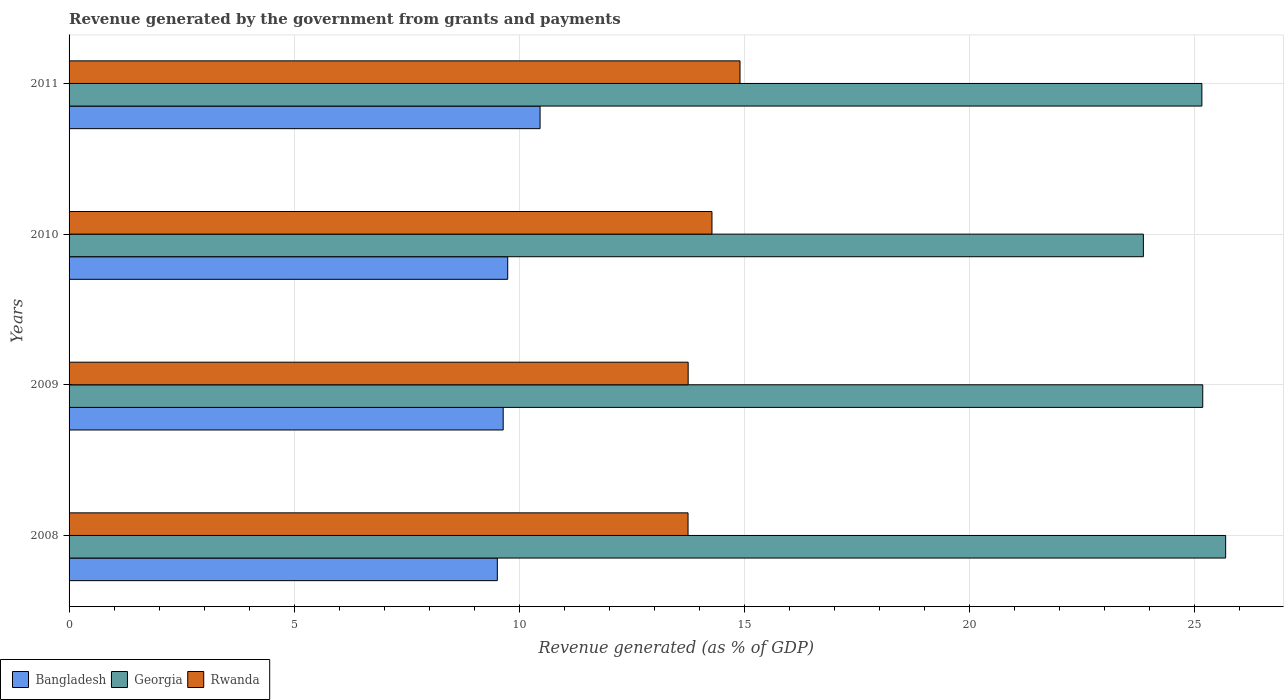How many different coloured bars are there?
Offer a very short reply. 3. How many bars are there on the 2nd tick from the top?
Give a very brief answer. 3. What is the revenue generated by the government in Bangladesh in 2011?
Make the answer very short. 10.46. Across all years, what is the maximum revenue generated by the government in Bangladesh?
Ensure brevity in your answer.  10.46. Across all years, what is the minimum revenue generated by the government in Bangladesh?
Your answer should be very brief. 9.51. What is the total revenue generated by the government in Georgia in the graph?
Provide a short and direct response. 99.9. What is the difference between the revenue generated by the government in Bangladesh in 2008 and that in 2010?
Your response must be concise. -0.23. What is the difference between the revenue generated by the government in Bangladesh in 2010 and the revenue generated by the government in Rwanda in 2008?
Your response must be concise. -4.01. What is the average revenue generated by the government in Bangladesh per year?
Provide a short and direct response. 9.84. In the year 2011, what is the difference between the revenue generated by the government in Georgia and revenue generated by the government in Rwanda?
Give a very brief answer. 10.26. What is the ratio of the revenue generated by the government in Georgia in 2009 to that in 2011?
Provide a succinct answer. 1. Is the revenue generated by the government in Rwanda in 2008 less than that in 2009?
Make the answer very short. Yes. Is the difference between the revenue generated by the government in Georgia in 2010 and 2011 greater than the difference between the revenue generated by the government in Rwanda in 2010 and 2011?
Your answer should be compact. No. What is the difference between the highest and the second highest revenue generated by the government in Bangladesh?
Your response must be concise. 0.72. What is the difference between the highest and the lowest revenue generated by the government in Rwanda?
Provide a short and direct response. 1.15. In how many years, is the revenue generated by the government in Rwanda greater than the average revenue generated by the government in Rwanda taken over all years?
Offer a terse response. 2. Is the sum of the revenue generated by the government in Rwanda in 2009 and 2010 greater than the maximum revenue generated by the government in Georgia across all years?
Offer a terse response. Yes. What does the 2nd bar from the top in 2010 represents?
Provide a succinct answer. Georgia. Does the graph contain grids?
Provide a short and direct response. Yes. Where does the legend appear in the graph?
Provide a succinct answer. Bottom left. How many legend labels are there?
Provide a short and direct response. 3. How are the legend labels stacked?
Offer a very short reply. Horizontal. What is the title of the graph?
Provide a short and direct response. Revenue generated by the government from grants and payments. What is the label or title of the X-axis?
Ensure brevity in your answer.  Revenue generated (as % of GDP). What is the label or title of the Y-axis?
Provide a short and direct response. Years. What is the Revenue generated (as % of GDP) of Bangladesh in 2008?
Offer a terse response. 9.51. What is the Revenue generated (as % of GDP) in Georgia in 2008?
Your answer should be compact. 25.69. What is the Revenue generated (as % of GDP) in Rwanda in 2008?
Your answer should be very brief. 13.75. What is the Revenue generated (as % of GDP) of Bangladesh in 2009?
Offer a terse response. 9.64. What is the Revenue generated (as % of GDP) of Georgia in 2009?
Offer a very short reply. 25.18. What is the Revenue generated (as % of GDP) in Rwanda in 2009?
Keep it short and to the point. 13.75. What is the Revenue generated (as % of GDP) in Bangladesh in 2010?
Your answer should be very brief. 9.74. What is the Revenue generated (as % of GDP) of Georgia in 2010?
Offer a terse response. 23.86. What is the Revenue generated (as % of GDP) of Rwanda in 2010?
Ensure brevity in your answer.  14.28. What is the Revenue generated (as % of GDP) in Bangladesh in 2011?
Ensure brevity in your answer.  10.46. What is the Revenue generated (as % of GDP) of Georgia in 2011?
Give a very brief answer. 25.16. What is the Revenue generated (as % of GDP) in Rwanda in 2011?
Keep it short and to the point. 14.9. Across all years, what is the maximum Revenue generated (as % of GDP) in Bangladesh?
Provide a succinct answer. 10.46. Across all years, what is the maximum Revenue generated (as % of GDP) of Georgia?
Provide a short and direct response. 25.69. Across all years, what is the maximum Revenue generated (as % of GDP) in Rwanda?
Your response must be concise. 14.9. Across all years, what is the minimum Revenue generated (as % of GDP) in Bangladesh?
Provide a succinct answer. 9.51. Across all years, what is the minimum Revenue generated (as % of GDP) in Georgia?
Your response must be concise. 23.86. Across all years, what is the minimum Revenue generated (as % of GDP) of Rwanda?
Your answer should be very brief. 13.75. What is the total Revenue generated (as % of GDP) of Bangladesh in the graph?
Your answer should be compact. 39.36. What is the total Revenue generated (as % of GDP) of Georgia in the graph?
Your answer should be compact. 99.9. What is the total Revenue generated (as % of GDP) of Rwanda in the graph?
Make the answer very short. 56.69. What is the difference between the Revenue generated (as % of GDP) in Bangladesh in 2008 and that in 2009?
Your answer should be very brief. -0.13. What is the difference between the Revenue generated (as % of GDP) in Georgia in 2008 and that in 2009?
Keep it short and to the point. 0.51. What is the difference between the Revenue generated (as % of GDP) of Rwanda in 2008 and that in 2009?
Provide a succinct answer. -0. What is the difference between the Revenue generated (as % of GDP) in Bangladesh in 2008 and that in 2010?
Your answer should be compact. -0.23. What is the difference between the Revenue generated (as % of GDP) in Georgia in 2008 and that in 2010?
Give a very brief answer. 1.83. What is the difference between the Revenue generated (as % of GDP) of Rwanda in 2008 and that in 2010?
Your response must be concise. -0.53. What is the difference between the Revenue generated (as % of GDP) of Bangladesh in 2008 and that in 2011?
Provide a succinct answer. -0.95. What is the difference between the Revenue generated (as % of GDP) of Georgia in 2008 and that in 2011?
Ensure brevity in your answer.  0.53. What is the difference between the Revenue generated (as % of GDP) in Rwanda in 2008 and that in 2011?
Give a very brief answer. -1.15. What is the difference between the Revenue generated (as % of GDP) in Bangladesh in 2009 and that in 2010?
Your response must be concise. -0.1. What is the difference between the Revenue generated (as % of GDP) of Georgia in 2009 and that in 2010?
Make the answer very short. 1.32. What is the difference between the Revenue generated (as % of GDP) in Rwanda in 2009 and that in 2010?
Your response must be concise. -0.53. What is the difference between the Revenue generated (as % of GDP) in Bangladesh in 2009 and that in 2011?
Your answer should be very brief. -0.82. What is the difference between the Revenue generated (as % of GDP) of Georgia in 2009 and that in 2011?
Your answer should be very brief. 0.02. What is the difference between the Revenue generated (as % of GDP) of Rwanda in 2009 and that in 2011?
Your answer should be compact. -1.15. What is the difference between the Revenue generated (as % of GDP) of Bangladesh in 2010 and that in 2011?
Keep it short and to the point. -0.72. What is the difference between the Revenue generated (as % of GDP) in Georgia in 2010 and that in 2011?
Your answer should be very brief. -1.3. What is the difference between the Revenue generated (as % of GDP) of Rwanda in 2010 and that in 2011?
Offer a terse response. -0.62. What is the difference between the Revenue generated (as % of GDP) in Bangladesh in 2008 and the Revenue generated (as % of GDP) in Georgia in 2009?
Your answer should be very brief. -15.67. What is the difference between the Revenue generated (as % of GDP) in Bangladesh in 2008 and the Revenue generated (as % of GDP) in Rwanda in 2009?
Offer a very short reply. -4.24. What is the difference between the Revenue generated (as % of GDP) of Georgia in 2008 and the Revenue generated (as % of GDP) of Rwanda in 2009?
Give a very brief answer. 11.94. What is the difference between the Revenue generated (as % of GDP) in Bangladesh in 2008 and the Revenue generated (as % of GDP) in Georgia in 2010?
Your answer should be compact. -14.35. What is the difference between the Revenue generated (as % of GDP) in Bangladesh in 2008 and the Revenue generated (as % of GDP) in Rwanda in 2010?
Make the answer very short. -4.77. What is the difference between the Revenue generated (as % of GDP) of Georgia in 2008 and the Revenue generated (as % of GDP) of Rwanda in 2010?
Your response must be concise. 11.41. What is the difference between the Revenue generated (as % of GDP) in Bangladesh in 2008 and the Revenue generated (as % of GDP) in Georgia in 2011?
Your answer should be compact. -15.65. What is the difference between the Revenue generated (as % of GDP) of Bangladesh in 2008 and the Revenue generated (as % of GDP) of Rwanda in 2011?
Keep it short and to the point. -5.39. What is the difference between the Revenue generated (as % of GDP) in Georgia in 2008 and the Revenue generated (as % of GDP) in Rwanda in 2011?
Make the answer very short. 10.79. What is the difference between the Revenue generated (as % of GDP) of Bangladesh in 2009 and the Revenue generated (as % of GDP) of Georgia in 2010?
Keep it short and to the point. -14.22. What is the difference between the Revenue generated (as % of GDP) of Bangladesh in 2009 and the Revenue generated (as % of GDP) of Rwanda in 2010?
Provide a short and direct response. -4.64. What is the difference between the Revenue generated (as % of GDP) of Georgia in 2009 and the Revenue generated (as % of GDP) of Rwanda in 2010?
Ensure brevity in your answer.  10.9. What is the difference between the Revenue generated (as % of GDP) in Bangladesh in 2009 and the Revenue generated (as % of GDP) in Georgia in 2011?
Offer a very short reply. -15.52. What is the difference between the Revenue generated (as % of GDP) in Bangladesh in 2009 and the Revenue generated (as % of GDP) in Rwanda in 2011?
Provide a short and direct response. -5.26. What is the difference between the Revenue generated (as % of GDP) in Georgia in 2009 and the Revenue generated (as % of GDP) in Rwanda in 2011?
Your response must be concise. 10.28. What is the difference between the Revenue generated (as % of GDP) of Bangladesh in 2010 and the Revenue generated (as % of GDP) of Georgia in 2011?
Offer a terse response. -15.42. What is the difference between the Revenue generated (as % of GDP) of Bangladesh in 2010 and the Revenue generated (as % of GDP) of Rwanda in 2011?
Your answer should be very brief. -5.16. What is the difference between the Revenue generated (as % of GDP) in Georgia in 2010 and the Revenue generated (as % of GDP) in Rwanda in 2011?
Your response must be concise. 8.96. What is the average Revenue generated (as % of GDP) of Bangladesh per year?
Give a very brief answer. 9.84. What is the average Revenue generated (as % of GDP) of Georgia per year?
Make the answer very short. 24.98. What is the average Revenue generated (as % of GDP) in Rwanda per year?
Offer a very short reply. 14.17. In the year 2008, what is the difference between the Revenue generated (as % of GDP) in Bangladesh and Revenue generated (as % of GDP) in Georgia?
Your response must be concise. -16.18. In the year 2008, what is the difference between the Revenue generated (as % of GDP) of Bangladesh and Revenue generated (as % of GDP) of Rwanda?
Give a very brief answer. -4.24. In the year 2008, what is the difference between the Revenue generated (as % of GDP) in Georgia and Revenue generated (as % of GDP) in Rwanda?
Offer a terse response. 11.94. In the year 2009, what is the difference between the Revenue generated (as % of GDP) in Bangladesh and Revenue generated (as % of GDP) in Georgia?
Keep it short and to the point. -15.54. In the year 2009, what is the difference between the Revenue generated (as % of GDP) of Bangladesh and Revenue generated (as % of GDP) of Rwanda?
Provide a short and direct response. -4.11. In the year 2009, what is the difference between the Revenue generated (as % of GDP) in Georgia and Revenue generated (as % of GDP) in Rwanda?
Your response must be concise. 11.43. In the year 2010, what is the difference between the Revenue generated (as % of GDP) in Bangladesh and Revenue generated (as % of GDP) in Georgia?
Provide a succinct answer. -14.12. In the year 2010, what is the difference between the Revenue generated (as % of GDP) in Bangladesh and Revenue generated (as % of GDP) in Rwanda?
Keep it short and to the point. -4.54. In the year 2010, what is the difference between the Revenue generated (as % of GDP) in Georgia and Revenue generated (as % of GDP) in Rwanda?
Your answer should be very brief. 9.58. In the year 2011, what is the difference between the Revenue generated (as % of GDP) in Bangladesh and Revenue generated (as % of GDP) in Georgia?
Offer a very short reply. -14.7. In the year 2011, what is the difference between the Revenue generated (as % of GDP) in Bangladesh and Revenue generated (as % of GDP) in Rwanda?
Offer a very short reply. -4.44. In the year 2011, what is the difference between the Revenue generated (as % of GDP) in Georgia and Revenue generated (as % of GDP) in Rwanda?
Your answer should be compact. 10.26. What is the ratio of the Revenue generated (as % of GDP) in Bangladesh in 2008 to that in 2009?
Your answer should be compact. 0.99. What is the ratio of the Revenue generated (as % of GDP) in Georgia in 2008 to that in 2009?
Offer a terse response. 1.02. What is the ratio of the Revenue generated (as % of GDP) in Rwanda in 2008 to that in 2009?
Ensure brevity in your answer.  1. What is the ratio of the Revenue generated (as % of GDP) of Bangladesh in 2008 to that in 2010?
Make the answer very short. 0.98. What is the ratio of the Revenue generated (as % of GDP) of Georgia in 2008 to that in 2010?
Your response must be concise. 1.08. What is the ratio of the Revenue generated (as % of GDP) in Rwanda in 2008 to that in 2010?
Offer a terse response. 0.96. What is the ratio of the Revenue generated (as % of GDP) of Bangladesh in 2008 to that in 2011?
Your response must be concise. 0.91. What is the ratio of the Revenue generated (as % of GDP) in Rwanda in 2008 to that in 2011?
Keep it short and to the point. 0.92. What is the ratio of the Revenue generated (as % of GDP) in Bangladesh in 2009 to that in 2010?
Your answer should be very brief. 0.99. What is the ratio of the Revenue generated (as % of GDP) of Georgia in 2009 to that in 2010?
Give a very brief answer. 1.06. What is the ratio of the Revenue generated (as % of GDP) of Bangladesh in 2009 to that in 2011?
Provide a succinct answer. 0.92. What is the ratio of the Revenue generated (as % of GDP) of Rwanda in 2009 to that in 2011?
Your answer should be compact. 0.92. What is the ratio of the Revenue generated (as % of GDP) in Bangladesh in 2010 to that in 2011?
Your answer should be compact. 0.93. What is the ratio of the Revenue generated (as % of GDP) of Georgia in 2010 to that in 2011?
Offer a very short reply. 0.95. What is the ratio of the Revenue generated (as % of GDP) in Rwanda in 2010 to that in 2011?
Ensure brevity in your answer.  0.96. What is the difference between the highest and the second highest Revenue generated (as % of GDP) in Bangladesh?
Provide a short and direct response. 0.72. What is the difference between the highest and the second highest Revenue generated (as % of GDP) of Georgia?
Provide a short and direct response. 0.51. What is the difference between the highest and the second highest Revenue generated (as % of GDP) in Rwanda?
Provide a succinct answer. 0.62. What is the difference between the highest and the lowest Revenue generated (as % of GDP) in Bangladesh?
Provide a succinct answer. 0.95. What is the difference between the highest and the lowest Revenue generated (as % of GDP) in Georgia?
Offer a terse response. 1.83. What is the difference between the highest and the lowest Revenue generated (as % of GDP) of Rwanda?
Your response must be concise. 1.15. 